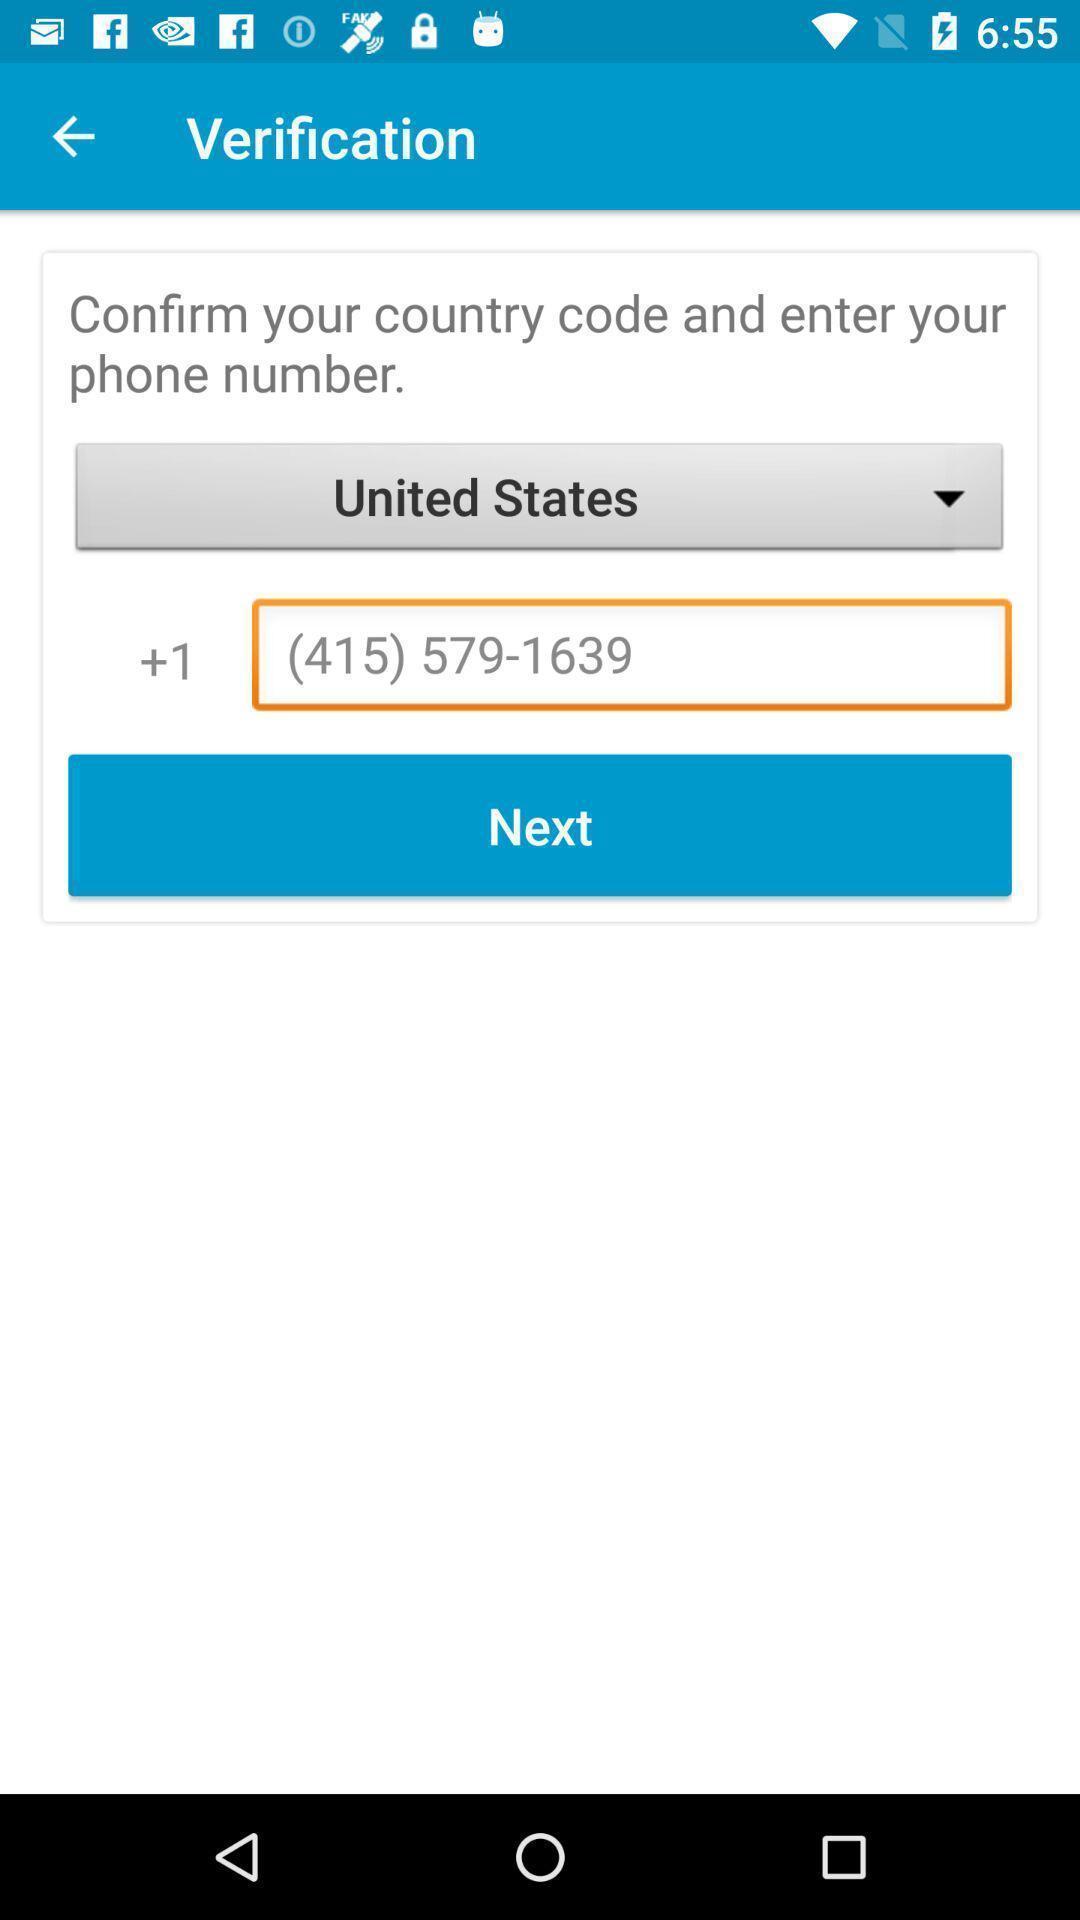Describe this image in words. Verification page to confirm number. 